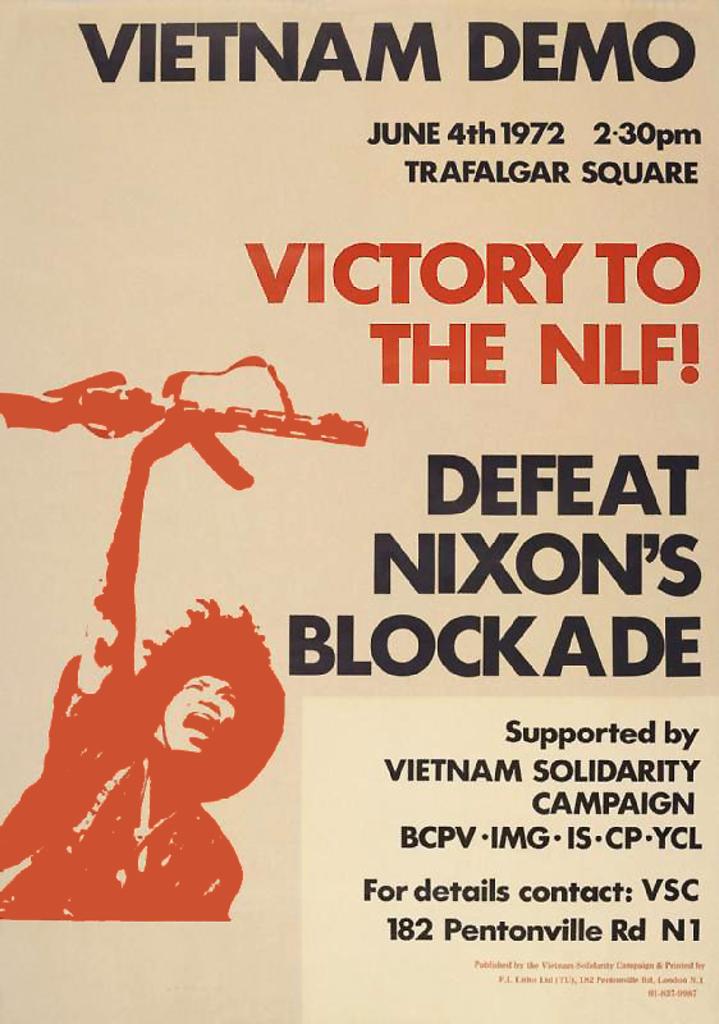What time is this show?
Provide a succinct answer. 2:30 pm. What road is in the contact?
Offer a very short reply. Pentonville. 